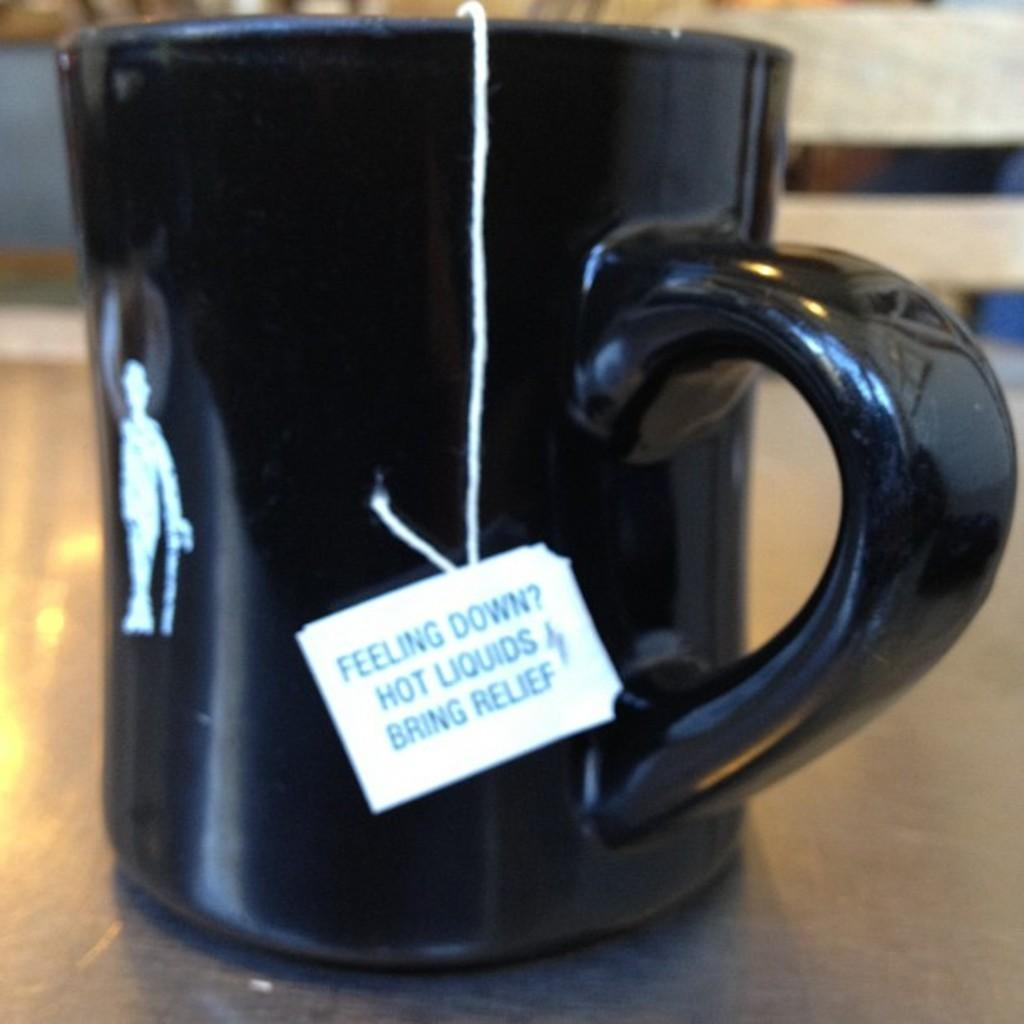<image>
Write a terse but informative summary of the picture. The tag of a teabag in a black mug explaining how hot liquids can bring relief. 